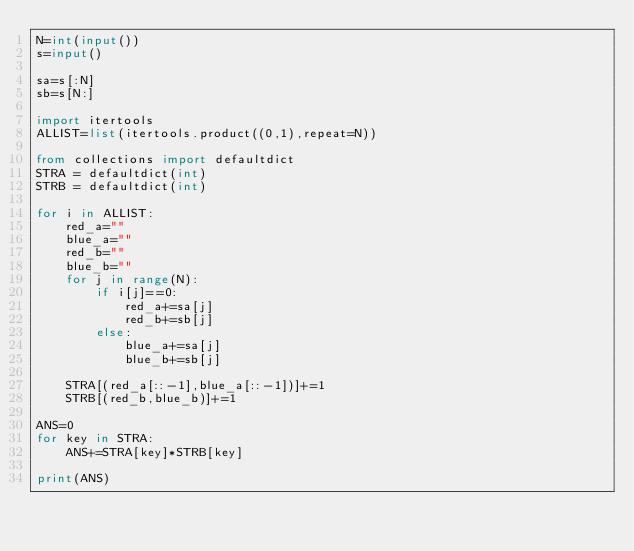Convert code to text. <code><loc_0><loc_0><loc_500><loc_500><_Python_>N=int(input())
s=input()

sa=s[:N]
sb=s[N:]

import itertools
ALLIST=list(itertools.product((0,1),repeat=N))

from collections import defaultdict
STRA = defaultdict(int)
STRB = defaultdict(int)

for i in ALLIST:
    red_a=""
    blue_a=""
    red_b=""
    blue_b=""
    for j in range(N):
        if i[j]==0:
            red_a+=sa[j]
            red_b+=sb[j]
        else:
            blue_a+=sa[j]
            blue_b+=sb[j]

    STRA[(red_a[::-1],blue_a[::-1])]+=1
    STRB[(red_b,blue_b)]+=1

ANS=0
for key in STRA:
    ANS+=STRA[key]*STRB[key]

print(ANS)</code> 